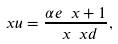Convert formula to latex. <formula><loc_0><loc_0><loc_500><loc_500>\ x u = \frac { \alpha e \ x + 1 } { \ x \ x d } ,</formula> 